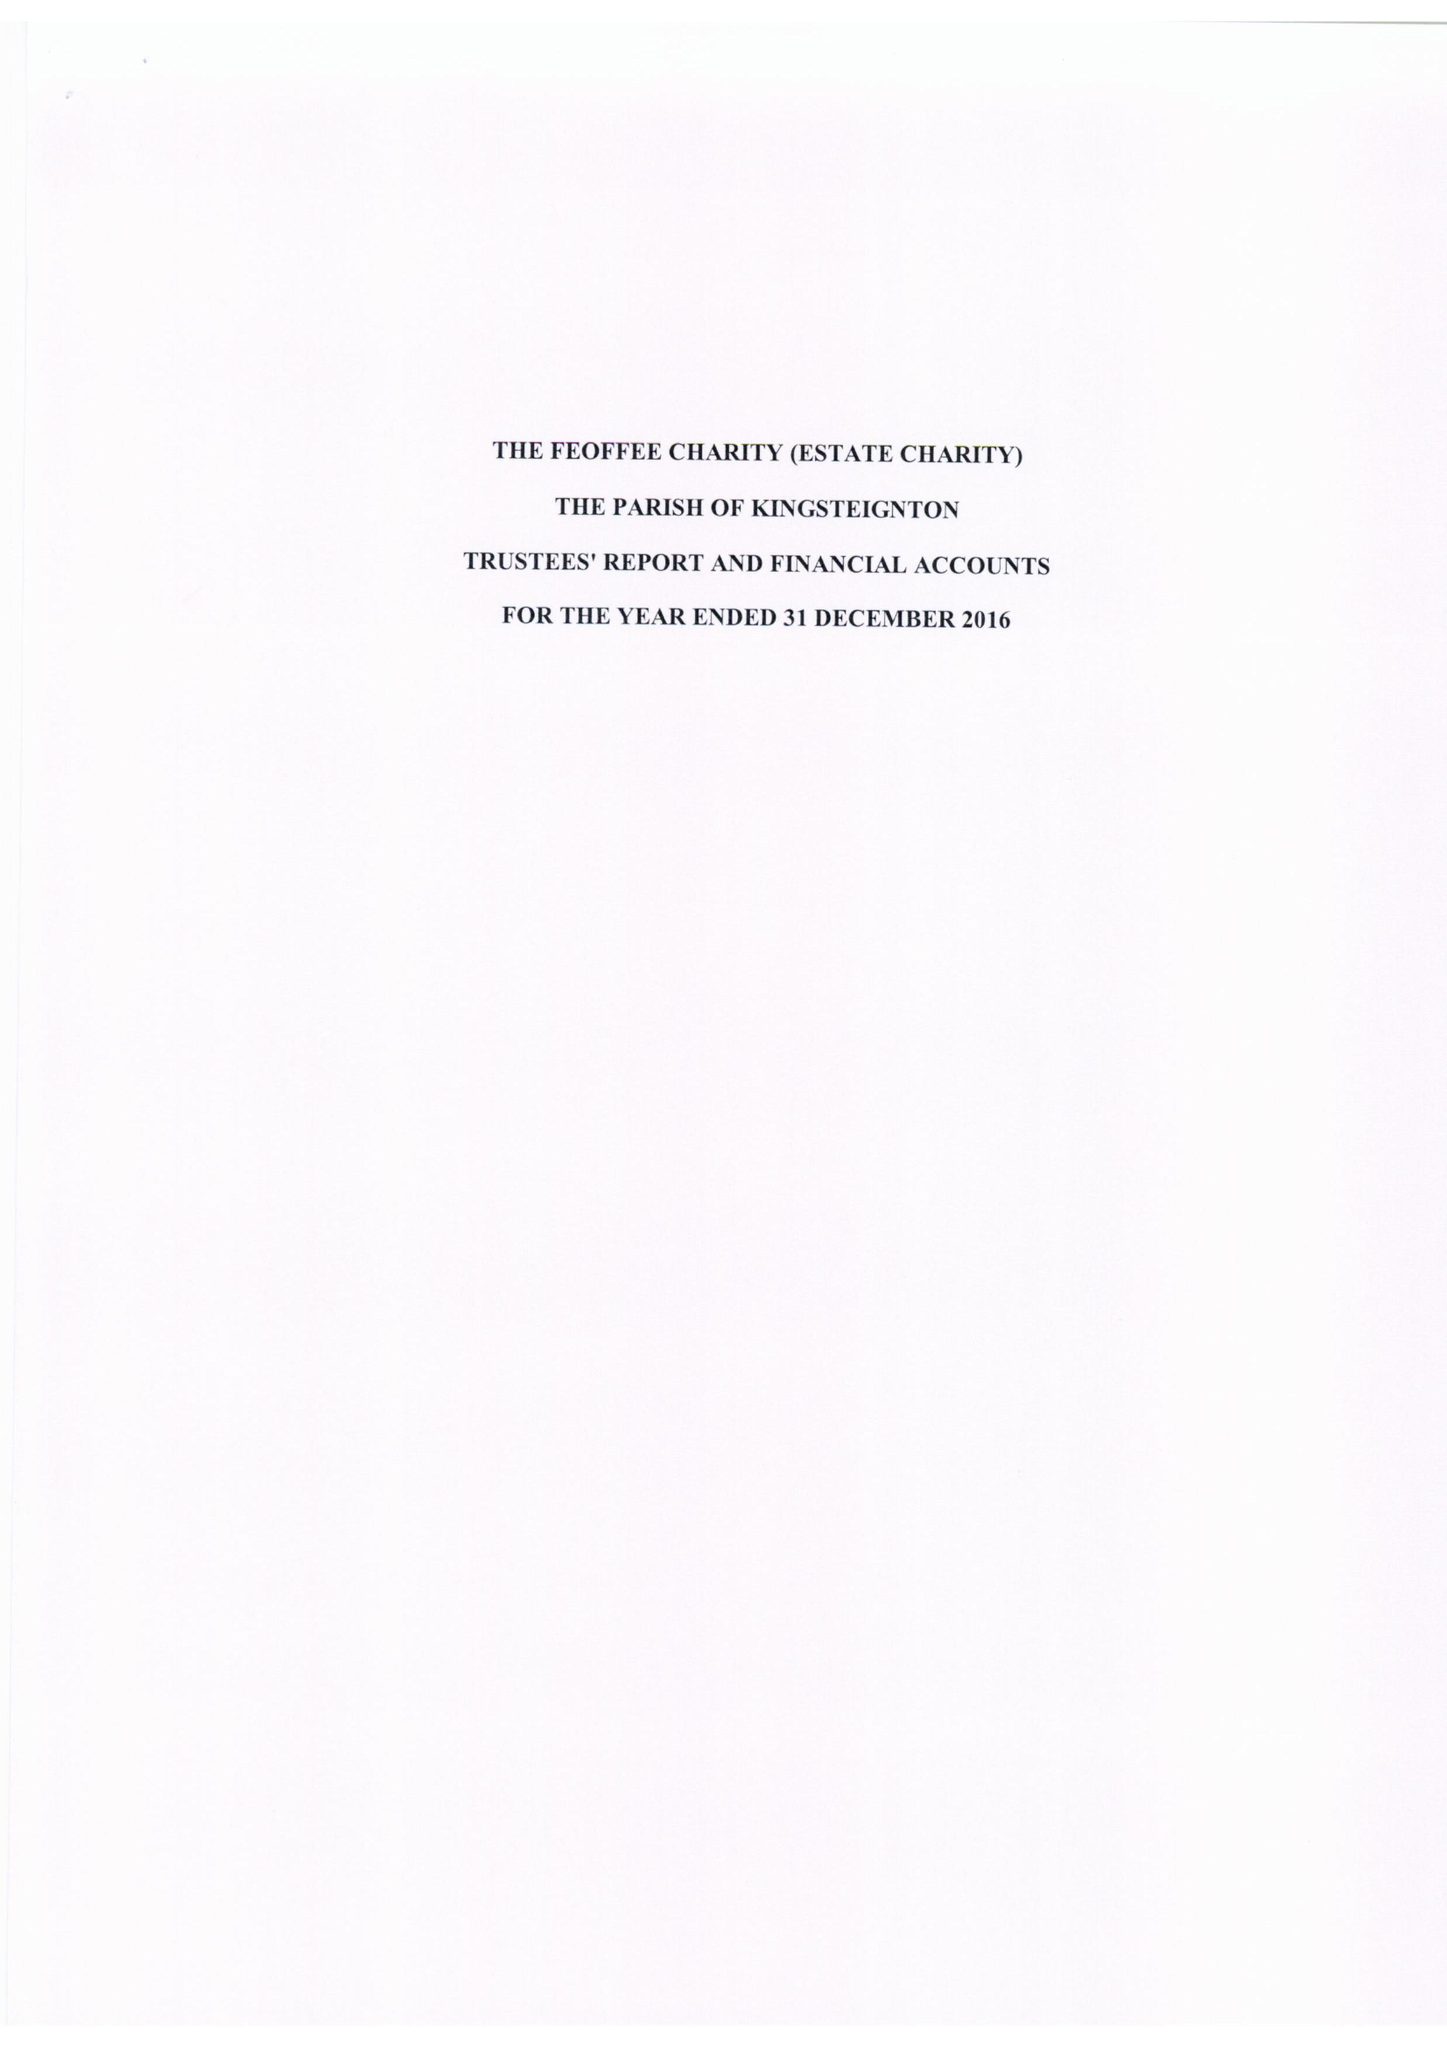What is the value for the spending_annually_in_british_pounds?
Answer the question using a single word or phrase. 25187.00 